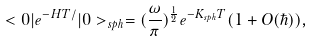Convert formula to latex. <formula><loc_0><loc_0><loc_500><loc_500>< 0 | e ^ { - H T / } | 0 > _ { s p h } = ( \frac { \omega } { \pi } ) ^ { \frac { 1 } { 2 } } e ^ { - K _ { s p h } T } ( 1 + O ( \hbar { ) } ) ,</formula> 